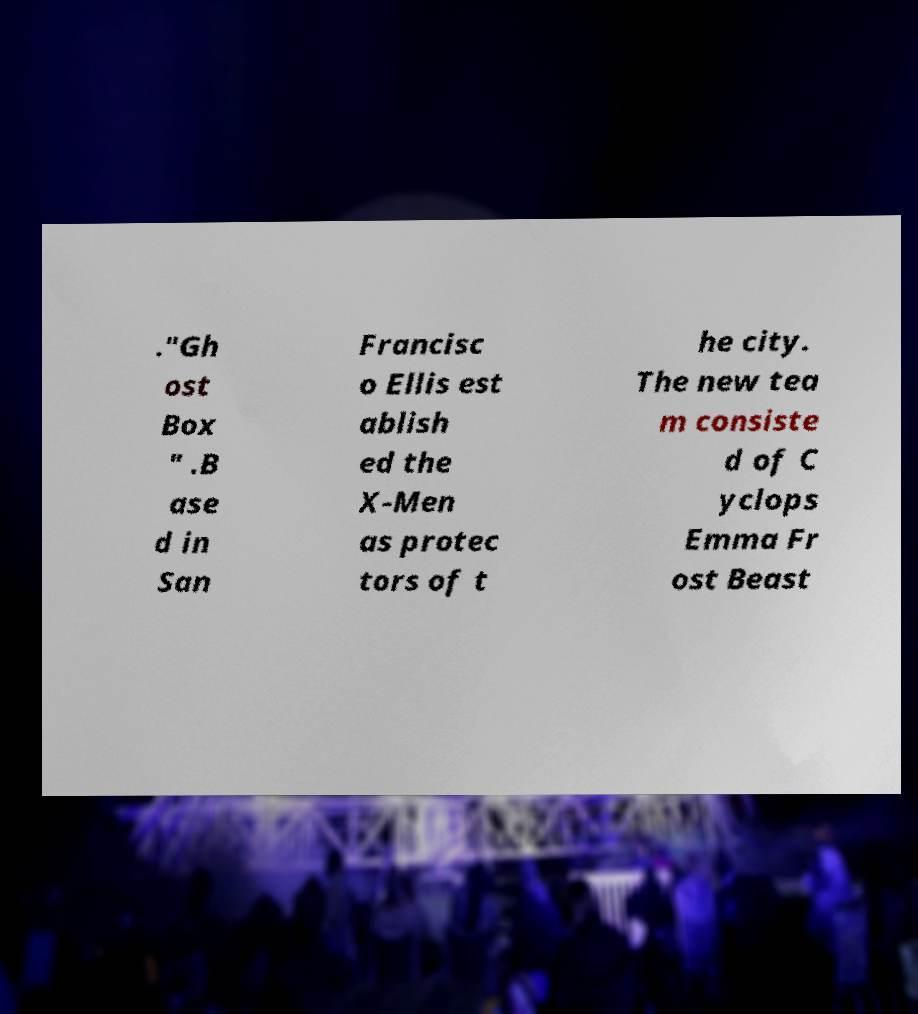Can you read and provide the text displayed in the image?This photo seems to have some interesting text. Can you extract and type it out for me? ."Gh ost Box " .B ase d in San Francisc o Ellis est ablish ed the X-Men as protec tors of t he city. The new tea m consiste d of C yclops Emma Fr ost Beast 